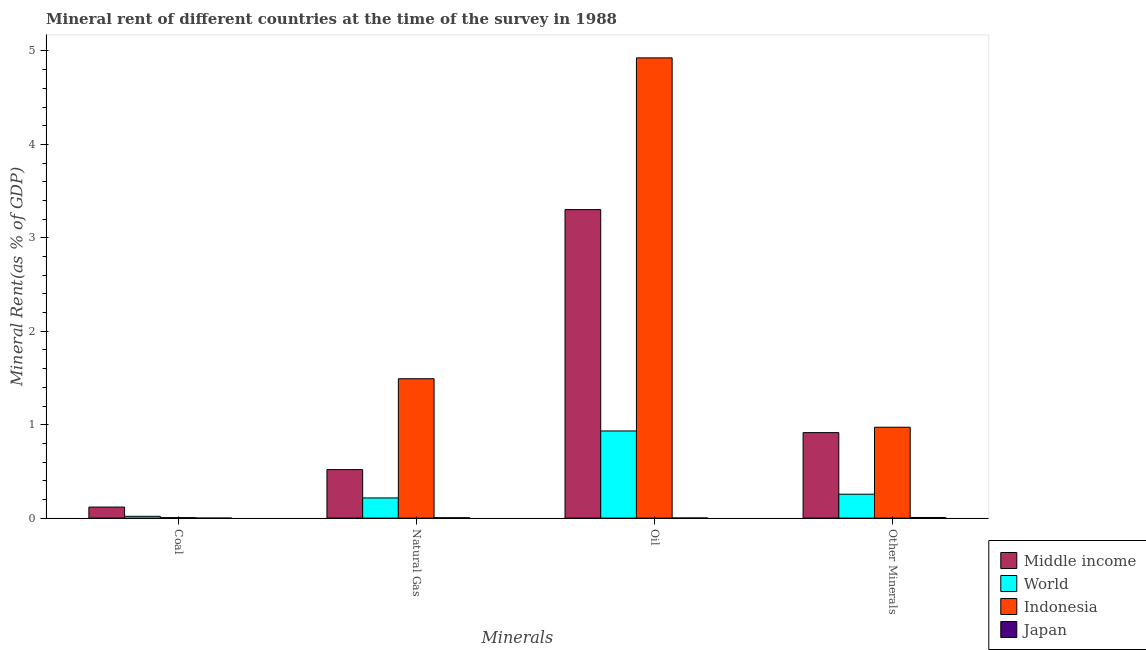How many different coloured bars are there?
Your response must be concise. 4. How many groups of bars are there?
Give a very brief answer. 4. What is the label of the 3rd group of bars from the left?
Offer a terse response. Oil. What is the natural gas rent in Middle income?
Provide a succinct answer. 0.52. Across all countries, what is the maximum oil rent?
Make the answer very short. 4.93. Across all countries, what is the minimum oil rent?
Your response must be concise. 0. In which country was the coal rent maximum?
Offer a very short reply. Middle income. What is the total oil rent in the graph?
Provide a short and direct response. 9.16. What is the difference between the oil rent in Japan and that in Middle income?
Your response must be concise. -3.3. What is the difference between the coal rent in Japan and the natural gas rent in Indonesia?
Your response must be concise. -1.49. What is the average coal rent per country?
Keep it short and to the point. 0.04. What is the difference between the  rent of other minerals and coal rent in Indonesia?
Provide a short and direct response. 0.97. In how many countries, is the coal rent greater than 3.8 %?
Make the answer very short. 0. What is the ratio of the coal rent in Indonesia to that in Middle income?
Provide a succinct answer. 0.04. What is the difference between the highest and the second highest coal rent?
Your response must be concise. 0.1. What is the difference between the highest and the lowest coal rent?
Give a very brief answer. 0.12. In how many countries, is the  rent of other minerals greater than the average  rent of other minerals taken over all countries?
Give a very brief answer. 2. What does the 2nd bar from the left in Natural Gas represents?
Your answer should be very brief. World. What does the 1st bar from the right in Natural Gas represents?
Give a very brief answer. Japan. Is it the case that in every country, the sum of the coal rent and natural gas rent is greater than the oil rent?
Make the answer very short. No. How many countries are there in the graph?
Provide a succinct answer. 4. What is the difference between two consecutive major ticks on the Y-axis?
Make the answer very short. 1. Does the graph contain any zero values?
Make the answer very short. No. How are the legend labels stacked?
Provide a succinct answer. Vertical. What is the title of the graph?
Provide a short and direct response. Mineral rent of different countries at the time of the survey in 1988. What is the label or title of the X-axis?
Offer a very short reply. Minerals. What is the label or title of the Y-axis?
Offer a very short reply. Mineral Rent(as % of GDP). What is the Mineral Rent(as % of GDP) of Middle income in Coal?
Your response must be concise. 0.12. What is the Mineral Rent(as % of GDP) of World in Coal?
Your answer should be compact. 0.02. What is the Mineral Rent(as % of GDP) in Indonesia in Coal?
Offer a very short reply. 0. What is the Mineral Rent(as % of GDP) of Japan in Coal?
Your response must be concise. 1.04103269481031e-6. What is the Mineral Rent(as % of GDP) in Middle income in Natural Gas?
Your answer should be very brief. 0.52. What is the Mineral Rent(as % of GDP) of World in Natural Gas?
Your answer should be compact. 0.22. What is the Mineral Rent(as % of GDP) of Indonesia in Natural Gas?
Provide a short and direct response. 1.49. What is the Mineral Rent(as % of GDP) of Japan in Natural Gas?
Provide a succinct answer. 0. What is the Mineral Rent(as % of GDP) of Middle income in Oil?
Your answer should be very brief. 3.3. What is the Mineral Rent(as % of GDP) of World in Oil?
Make the answer very short. 0.93. What is the Mineral Rent(as % of GDP) of Indonesia in Oil?
Provide a short and direct response. 4.93. What is the Mineral Rent(as % of GDP) in Japan in Oil?
Give a very brief answer. 0. What is the Mineral Rent(as % of GDP) of Middle income in Other Minerals?
Give a very brief answer. 0.92. What is the Mineral Rent(as % of GDP) of World in Other Minerals?
Make the answer very short. 0.26. What is the Mineral Rent(as % of GDP) of Indonesia in Other Minerals?
Give a very brief answer. 0.97. What is the Mineral Rent(as % of GDP) of Japan in Other Minerals?
Provide a succinct answer. 0.01. Across all Minerals, what is the maximum Mineral Rent(as % of GDP) of Middle income?
Ensure brevity in your answer.  3.3. Across all Minerals, what is the maximum Mineral Rent(as % of GDP) of World?
Provide a short and direct response. 0.93. Across all Minerals, what is the maximum Mineral Rent(as % of GDP) of Indonesia?
Provide a short and direct response. 4.93. Across all Minerals, what is the maximum Mineral Rent(as % of GDP) in Japan?
Your answer should be very brief. 0.01. Across all Minerals, what is the minimum Mineral Rent(as % of GDP) in Middle income?
Your answer should be very brief. 0.12. Across all Minerals, what is the minimum Mineral Rent(as % of GDP) in World?
Make the answer very short. 0.02. Across all Minerals, what is the minimum Mineral Rent(as % of GDP) of Indonesia?
Ensure brevity in your answer.  0. Across all Minerals, what is the minimum Mineral Rent(as % of GDP) of Japan?
Make the answer very short. 1.04103269481031e-6. What is the total Mineral Rent(as % of GDP) in Middle income in the graph?
Offer a very short reply. 4.85. What is the total Mineral Rent(as % of GDP) of World in the graph?
Offer a very short reply. 1.42. What is the total Mineral Rent(as % of GDP) in Indonesia in the graph?
Ensure brevity in your answer.  7.4. What is the total Mineral Rent(as % of GDP) of Japan in the graph?
Provide a succinct answer. 0.01. What is the difference between the Mineral Rent(as % of GDP) of Middle income in Coal and that in Natural Gas?
Offer a terse response. -0.4. What is the difference between the Mineral Rent(as % of GDP) of World in Coal and that in Natural Gas?
Your answer should be very brief. -0.2. What is the difference between the Mineral Rent(as % of GDP) in Indonesia in Coal and that in Natural Gas?
Keep it short and to the point. -1.49. What is the difference between the Mineral Rent(as % of GDP) of Japan in Coal and that in Natural Gas?
Offer a terse response. -0. What is the difference between the Mineral Rent(as % of GDP) in Middle income in Coal and that in Oil?
Offer a terse response. -3.18. What is the difference between the Mineral Rent(as % of GDP) in World in Coal and that in Oil?
Offer a terse response. -0.91. What is the difference between the Mineral Rent(as % of GDP) in Indonesia in Coal and that in Oil?
Offer a very short reply. -4.92. What is the difference between the Mineral Rent(as % of GDP) in Japan in Coal and that in Oil?
Give a very brief answer. -0. What is the difference between the Mineral Rent(as % of GDP) in Middle income in Coal and that in Other Minerals?
Offer a terse response. -0.8. What is the difference between the Mineral Rent(as % of GDP) of World in Coal and that in Other Minerals?
Your answer should be compact. -0.24. What is the difference between the Mineral Rent(as % of GDP) in Indonesia in Coal and that in Other Minerals?
Offer a terse response. -0.97. What is the difference between the Mineral Rent(as % of GDP) in Japan in Coal and that in Other Minerals?
Ensure brevity in your answer.  -0.01. What is the difference between the Mineral Rent(as % of GDP) of Middle income in Natural Gas and that in Oil?
Offer a very short reply. -2.78. What is the difference between the Mineral Rent(as % of GDP) in World in Natural Gas and that in Oil?
Keep it short and to the point. -0.72. What is the difference between the Mineral Rent(as % of GDP) in Indonesia in Natural Gas and that in Oil?
Your response must be concise. -3.43. What is the difference between the Mineral Rent(as % of GDP) of Japan in Natural Gas and that in Oil?
Offer a terse response. 0. What is the difference between the Mineral Rent(as % of GDP) of Middle income in Natural Gas and that in Other Minerals?
Your response must be concise. -0.4. What is the difference between the Mineral Rent(as % of GDP) in World in Natural Gas and that in Other Minerals?
Your response must be concise. -0.04. What is the difference between the Mineral Rent(as % of GDP) of Indonesia in Natural Gas and that in Other Minerals?
Ensure brevity in your answer.  0.52. What is the difference between the Mineral Rent(as % of GDP) in Japan in Natural Gas and that in Other Minerals?
Your answer should be compact. -0. What is the difference between the Mineral Rent(as % of GDP) in Middle income in Oil and that in Other Minerals?
Offer a terse response. 2.39. What is the difference between the Mineral Rent(as % of GDP) in World in Oil and that in Other Minerals?
Your answer should be very brief. 0.68. What is the difference between the Mineral Rent(as % of GDP) in Indonesia in Oil and that in Other Minerals?
Offer a terse response. 3.95. What is the difference between the Mineral Rent(as % of GDP) in Japan in Oil and that in Other Minerals?
Your answer should be very brief. -0.01. What is the difference between the Mineral Rent(as % of GDP) in Middle income in Coal and the Mineral Rent(as % of GDP) in World in Natural Gas?
Make the answer very short. -0.1. What is the difference between the Mineral Rent(as % of GDP) of Middle income in Coal and the Mineral Rent(as % of GDP) of Indonesia in Natural Gas?
Ensure brevity in your answer.  -1.37. What is the difference between the Mineral Rent(as % of GDP) in Middle income in Coal and the Mineral Rent(as % of GDP) in Japan in Natural Gas?
Offer a terse response. 0.11. What is the difference between the Mineral Rent(as % of GDP) in World in Coal and the Mineral Rent(as % of GDP) in Indonesia in Natural Gas?
Offer a very short reply. -1.47. What is the difference between the Mineral Rent(as % of GDP) in World in Coal and the Mineral Rent(as % of GDP) in Japan in Natural Gas?
Keep it short and to the point. 0.02. What is the difference between the Mineral Rent(as % of GDP) in Indonesia in Coal and the Mineral Rent(as % of GDP) in Japan in Natural Gas?
Give a very brief answer. 0. What is the difference between the Mineral Rent(as % of GDP) in Middle income in Coal and the Mineral Rent(as % of GDP) in World in Oil?
Provide a succinct answer. -0.81. What is the difference between the Mineral Rent(as % of GDP) of Middle income in Coal and the Mineral Rent(as % of GDP) of Indonesia in Oil?
Offer a terse response. -4.81. What is the difference between the Mineral Rent(as % of GDP) of Middle income in Coal and the Mineral Rent(as % of GDP) of Japan in Oil?
Offer a very short reply. 0.12. What is the difference between the Mineral Rent(as % of GDP) of World in Coal and the Mineral Rent(as % of GDP) of Indonesia in Oil?
Give a very brief answer. -4.91. What is the difference between the Mineral Rent(as % of GDP) of World in Coal and the Mineral Rent(as % of GDP) of Japan in Oil?
Your answer should be compact. 0.02. What is the difference between the Mineral Rent(as % of GDP) in Indonesia in Coal and the Mineral Rent(as % of GDP) in Japan in Oil?
Offer a very short reply. 0. What is the difference between the Mineral Rent(as % of GDP) in Middle income in Coal and the Mineral Rent(as % of GDP) in World in Other Minerals?
Provide a succinct answer. -0.14. What is the difference between the Mineral Rent(as % of GDP) of Middle income in Coal and the Mineral Rent(as % of GDP) of Indonesia in Other Minerals?
Give a very brief answer. -0.85. What is the difference between the Mineral Rent(as % of GDP) of Middle income in Coal and the Mineral Rent(as % of GDP) of Japan in Other Minerals?
Provide a succinct answer. 0.11. What is the difference between the Mineral Rent(as % of GDP) of World in Coal and the Mineral Rent(as % of GDP) of Indonesia in Other Minerals?
Offer a very short reply. -0.95. What is the difference between the Mineral Rent(as % of GDP) in World in Coal and the Mineral Rent(as % of GDP) in Japan in Other Minerals?
Offer a very short reply. 0.01. What is the difference between the Mineral Rent(as % of GDP) of Indonesia in Coal and the Mineral Rent(as % of GDP) of Japan in Other Minerals?
Provide a short and direct response. -0. What is the difference between the Mineral Rent(as % of GDP) in Middle income in Natural Gas and the Mineral Rent(as % of GDP) in World in Oil?
Your answer should be very brief. -0.41. What is the difference between the Mineral Rent(as % of GDP) in Middle income in Natural Gas and the Mineral Rent(as % of GDP) in Indonesia in Oil?
Your answer should be very brief. -4.41. What is the difference between the Mineral Rent(as % of GDP) in Middle income in Natural Gas and the Mineral Rent(as % of GDP) in Japan in Oil?
Offer a terse response. 0.52. What is the difference between the Mineral Rent(as % of GDP) in World in Natural Gas and the Mineral Rent(as % of GDP) in Indonesia in Oil?
Make the answer very short. -4.71. What is the difference between the Mineral Rent(as % of GDP) in World in Natural Gas and the Mineral Rent(as % of GDP) in Japan in Oil?
Give a very brief answer. 0.21. What is the difference between the Mineral Rent(as % of GDP) in Indonesia in Natural Gas and the Mineral Rent(as % of GDP) in Japan in Oil?
Provide a succinct answer. 1.49. What is the difference between the Mineral Rent(as % of GDP) in Middle income in Natural Gas and the Mineral Rent(as % of GDP) in World in Other Minerals?
Your response must be concise. 0.26. What is the difference between the Mineral Rent(as % of GDP) of Middle income in Natural Gas and the Mineral Rent(as % of GDP) of Indonesia in Other Minerals?
Your answer should be very brief. -0.45. What is the difference between the Mineral Rent(as % of GDP) in Middle income in Natural Gas and the Mineral Rent(as % of GDP) in Japan in Other Minerals?
Your answer should be very brief. 0.51. What is the difference between the Mineral Rent(as % of GDP) in World in Natural Gas and the Mineral Rent(as % of GDP) in Indonesia in Other Minerals?
Your answer should be compact. -0.76. What is the difference between the Mineral Rent(as % of GDP) of World in Natural Gas and the Mineral Rent(as % of GDP) of Japan in Other Minerals?
Offer a terse response. 0.21. What is the difference between the Mineral Rent(as % of GDP) in Indonesia in Natural Gas and the Mineral Rent(as % of GDP) in Japan in Other Minerals?
Your response must be concise. 1.49. What is the difference between the Mineral Rent(as % of GDP) of Middle income in Oil and the Mineral Rent(as % of GDP) of World in Other Minerals?
Provide a short and direct response. 3.05. What is the difference between the Mineral Rent(as % of GDP) in Middle income in Oil and the Mineral Rent(as % of GDP) in Indonesia in Other Minerals?
Your answer should be compact. 2.33. What is the difference between the Mineral Rent(as % of GDP) in Middle income in Oil and the Mineral Rent(as % of GDP) in Japan in Other Minerals?
Make the answer very short. 3.3. What is the difference between the Mineral Rent(as % of GDP) in World in Oil and the Mineral Rent(as % of GDP) in Indonesia in Other Minerals?
Give a very brief answer. -0.04. What is the difference between the Mineral Rent(as % of GDP) in World in Oil and the Mineral Rent(as % of GDP) in Japan in Other Minerals?
Your response must be concise. 0.93. What is the difference between the Mineral Rent(as % of GDP) in Indonesia in Oil and the Mineral Rent(as % of GDP) in Japan in Other Minerals?
Make the answer very short. 4.92. What is the average Mineral Rent(as % of GDP) in Middle income per Minerals?
Provide a short and direct response. 1.21. What is the average Mineral Rent(as % of GDP) in World per Minerals?
Offer a very short reply. 0.36. What is the average Mineral Rent(as % of GDP) in Indonesia per Minerals?
Provide a short and direct response. 1.85. What is the average Mineral Rent(as % of GDP) in Japan per Minerals?
Make the answer very short. 0. What is the difference between the Mineral Rent(as % of GDP) of Middle income and Mineral Rent(as % of GDP) of World in Coal?
Your answer should be very brief. 0.1. What is the difference between the Mineral Rent(as % of GDP) of Middle income and Mineral Rent(as % of GDP) of Indonesia in Coal?
Offer a very short reply. 0.11. What is the difference between the Mineral Rent(as % of GDP) in Middle income and Mineral Rent(as % of GDP) in Japan in Coal?
Provide a succinct answer. 0.12. What is the difference between the Mineral Rent(as % of GDP) in World and Mineral Rent(as % of GDP) in Indonesia in Coal?
Offer a terse response. 0.01. What is the difference between the Mineral Rent(as % of GDP) of World and Mineral Rent(as % of GDP) of Japan in Coal?
Offer a very short reply. 0.02. What is the difference between the Mineral Rent(as % of GDP) of Indonesia and Mineral Rent(as % of GDP) of Japan in Coal?
Your response must be concise. 0. What is the difference between the Mineral Rent(as % of GDP) in Middle income and Mineral Rent(as % of GDP) in World in Natural Gas?
Give a very brief answer. 0.3. What is the difference between the Mineral Rent(as % of GDP) in Middle income and Mineral Rent(as % of GDP) in Indonesia in Natural Gas?
Offer a very short reply. -0.97. What is the difference between the Mineral Rent(as % of GDP) in Middle income and Mineral Rent(as % of GDP) in Japan in Natural Gas?
Make the answer very short. 0.52. What is the difference between the Mineral Rent(as % of GDP) of World and Mineral Rent(as % of GDP) of Indonesia in Natural Gas?
Provide a short and direct response. -1.28. What is the difference between the Mineral Rent(as % of GDP) in World and Mineral Rent(as % of GDP) in Japan in Natural Gas?
Provide a succinct answer. 0.21. What is the difference between the Mineral Rent(as % of GDP) in Indonesia and Mineral Rent(as % of GDP) in Japan in Natural Gas?
Make the answer very short. 1.49. What is the difference between the Mineral Rent(as % of GDP) in Middle income and Mineral Rent(as % of GDP) in World in Oil?
Your response must be concise. 2.37. What is the difference between the Mineral Rent(as % of GDP) in Middle income and Mineral Rent(as % of GDP) in Indonesia in Oil?
Provide a short and direct response. -1.62. What is the difference between the Mineral Rent(as % of GDP) of Middle income and Mineral Rent(as % of GDP) of Japan in Oil?
Provide a short and direct response. 3.3. What is the difference between the Mineral Rent(as % of GDP) of World and Mineral Rent(as % of GDP) of Indonesia in Oil?
Offer a very short reply. -3.99. What is the difference between the Mineral Rent(as % of GDP) in World and Mineral Rent(as % of GDP) in Japan in Oil?
Provide a short and direct response. 0.93. What is the difference between the Mineral Rent(as % of GDP) of Indonesia and Mineral Rent(as % of GDP) of Japan in Oil?
Offer a very short reply. 4.92. What is the difference between the Mineral Rent(as % of GDP) of Middle income and Mineral Rent(as % of GDP) of World in Other Minerals?
Your answer should be very brief. 0.66. What is the difference between the Mineral Rent(as % of GDP) of Middle income and Mineral Rent(as % of GDP) of Indonesia in Other Minerals?
Keep it short and to the point. -0.06. What is the difference between the Mineral Rent(as % of GDP) in Middle income and Mineral Rent(as % of GDP) in Japan in Other Minerals?
Your answer should be compact. 0.91. What is the difference between the Mineral Rent(as % of GDP) in World and Mineral Rent(as % of GDP) in Indonesia in Other Minerals?
Keep it short and to the point. -0.72. What is the difference between the Mineral Rent(as % of GDP) of World and Mineral Rent(as % of GDP) of Japan in Other Minerals?
Offer a very short reply. 0.25. What is the difference between the Mineral Rent(as % of GDP) of Indonesia and Mineral Rent(as % of GDP) of Japan in Other Minerals?
Your response must be concise. 0.97. What is the ratio of the Mineral Rent(as % of GDP) in Middle income in Coal to that in Natural Gas?
Ensure brevity in your answer.  0.23. What is the ratio of the Mineral Rent(as % of GDP) in World in Coal to that in Natural Gas?
Make the answer very short. 0.09. What is the ratio of the Mineral Rent(as % of GDP) of Indonesia in Coal to that in Natural Gas?
Make the answer very short. 0. What is the ratio of the Mineral Rent(as % of GDP) of Middle income in Coal to that in Oil?
Keep it short and to the point. 0.04. What is the ratio of the Mineral Rent(as % of GDP) of World in Coal to that in Oil?
Your answer should be compact. 0.02. What is the ratio of the Mineral Rent(as % of GDP) in Indonesia in Coal to that in Oil?
Provide a succinct answer. 0. What is the ratio of the Mineral Rent(as % of GDP) of Japan in Coal to that in Oil?
Give a very brief answer. 0. What is the ratio of the Mineral Rent(as % of GDP) in Middle income in Coal to that in Other Minerals?
Ensure brevity in your answer.  0.13. What is the ratio of the Mineral Rent(as % of GDP) in World in Coal to that in Other Minerals?
Your answer should be compact. 0.08. What is the ratio of the Mineral Rent(as % of GDP) of Indonesia in Coal to that in Other Minerals?
Make the answer very short. 0.01. What is the ratio of the Mineral Rent(as % of GDP) of Japan in Coal to that in Other Minerals?
Offer a terse response. 0. What is the ratio of the Mineral Rent(as % of GDP) of Middle income in Natural Gas to that in Oil?
Your answer should be compact. 0.16. What is the ratio of the Mineral Rent(as % of GDP) of World in Natural Gas to that in Oil?
Keep it short and to the point. 0.23. What is the ratio of the Mineral Rent(as % of GDP) of Indonesia in Natural Gas to that in Oil?
Give a very brief answer. 0.3. What is the ratio of the Mineral Rent(as % of GDP) of Japan in Natural Gas to that in Oil?
Provide a succinct answer. 3.32. What is the ratio of the Mineral Rent(as % of GDP) in Middle income in Natural Gas to that in Other Minerals?
Offer a very short reply. 0.57. What is the ratio of the Mineral Rent(as % of GDP) in World in Natural Gas to that in Other Minerals?
Your answer should be very brief. 0.84. What is the ratio of the Mineral Rent(as % of GDP) in Indonesia in Natural Gas to that in Other Minerals?
Provide a short and direct response. 1.53. What is the ratio of the Mineral Rent(as % of GDP) in Japan in Natural Gas to that in Other Minerals?
Give a very brief answer. 0.57. What is the ratio of the Mineral Rent(as % of GDP) of Middle income in Oil to that in Other Minerals?
Your answer should be compact. 3.61. What is the ratio of the Mineral Rent(as % of GDP) in World in Oil to that in Other Minerals?
Provide a short and direct response. 3.65. What is the ratio of the Mineral Rent(as % of GDP) in Indonesia in Oil to that in Other Minerals?
Your response must be concise. 5.06. What is the ratio of the Mineral Rent(as % of GDP) of Japan in Oil to that in Other Minerals?
Provide a short and direct response. 0.17. What is the difference between the highest and the second highest Mineral Rent(as % of GDP) in Middle income?
Your answer should be compact. 2.39. What is the difference between the highest and the second highest Mineral Rent(as % of GDP) in World?
Provide a succinct answer. 0.68. What is the difference between the highest and the second highest Mineral Rent(as % of GDP) of Indonesia?
Make the answer very short. 3.43. What is the difference between the highest and the second highest Mineral Rent(as % of GDP) of Japan?
Provide a short and direct response. 0. What is the difference between the highest and the lowest Mineral Rent(as % of GDP) of Middle income?
Ensure brevity in your answer.  3.18. What is the difference between the highest and the lowest Mineral Rent(as % of GDP) of World?
Your answer should be compact. 0.91. What is the difference between the highest and the lowest Mineral Rent(as % of GDP) in Indonesia?
Ensure brevity in your answer.  4.92. What is the difference between the highest and the lowest Mineral Rent(as % of GDP) of Japan?
Your answer should be compact. 0.01. 